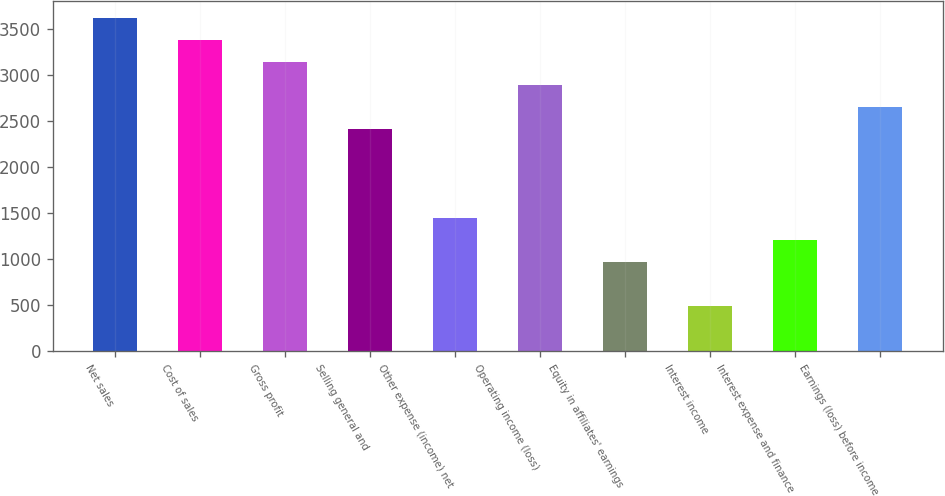<chart> <loc_0><loc_0><loc_500><loc_500><bar_chart><fcel>Net sales<fcel>Cost of sales<fcel>Gross profit<fcel>Selling general and<fcel>Other expense (income) net<fcel>Operating income (loss)<fcel>Equity in affiliates' earnings<fcel>Interest income<fcel>Interest expense and finance<fcel>Earnings (loss) before income<nl><fcel>3623.83<fcel>3382.3<fcel>3140.77<fcel>2416.18<fcel>1450.06<fcel>2899.24<fcel>967<fcel>483.94<fcel>1208.53<fcel>2657.71<nl></chart> 